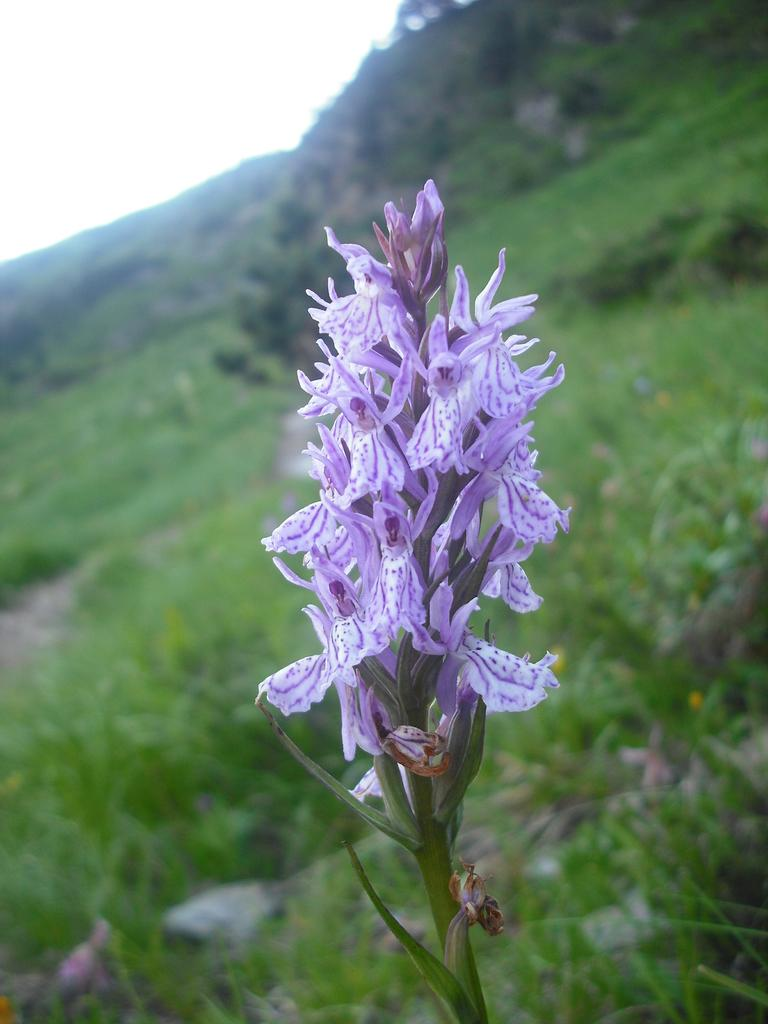What type of plant is depicted in the image? There are flowers on a stem in the image. Can you describe the background of the image? The background is green and blurry. What type of soap is being used to clean the club in the image? There is no soap, club, or cleaning activity depicted in the image; it features flowers on a stem with a green and blurry background. 